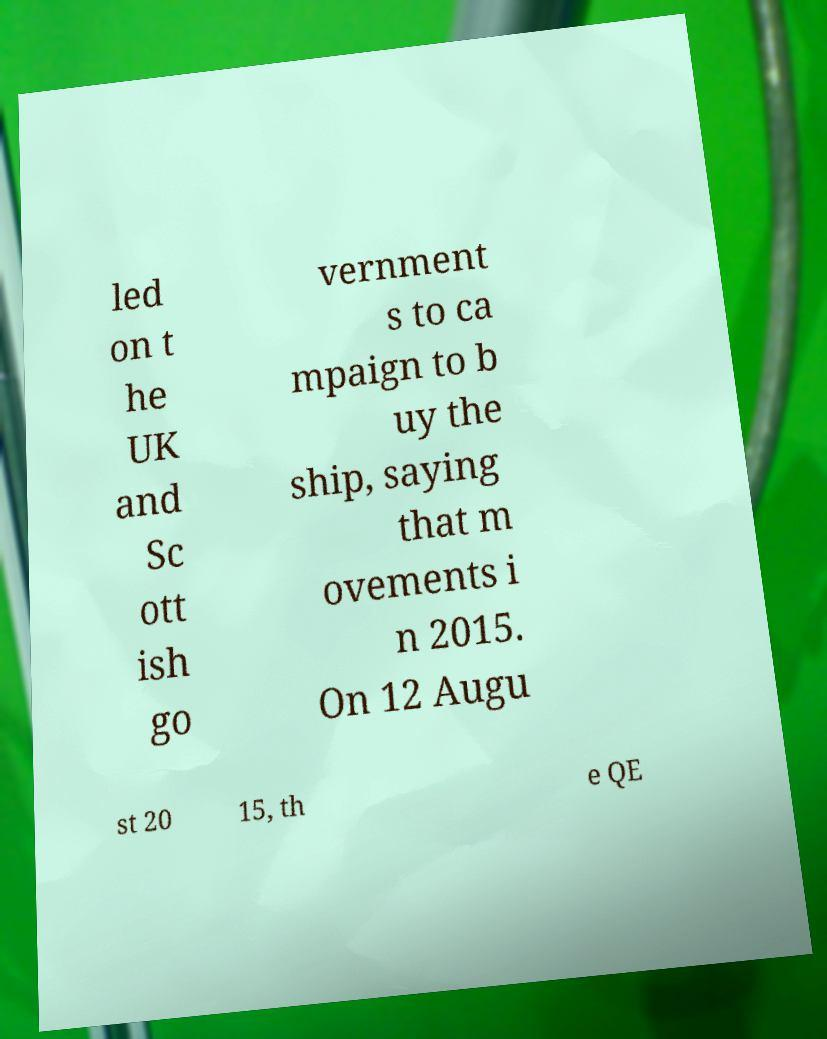Please read and relay the text visible in this image. What does it say? led on t he UK and Sc ott ish go vernment s to ca mpaign to b uy the ship, saying that m ovements i n 2015. On 12 Augu st 20 15, th e QE 